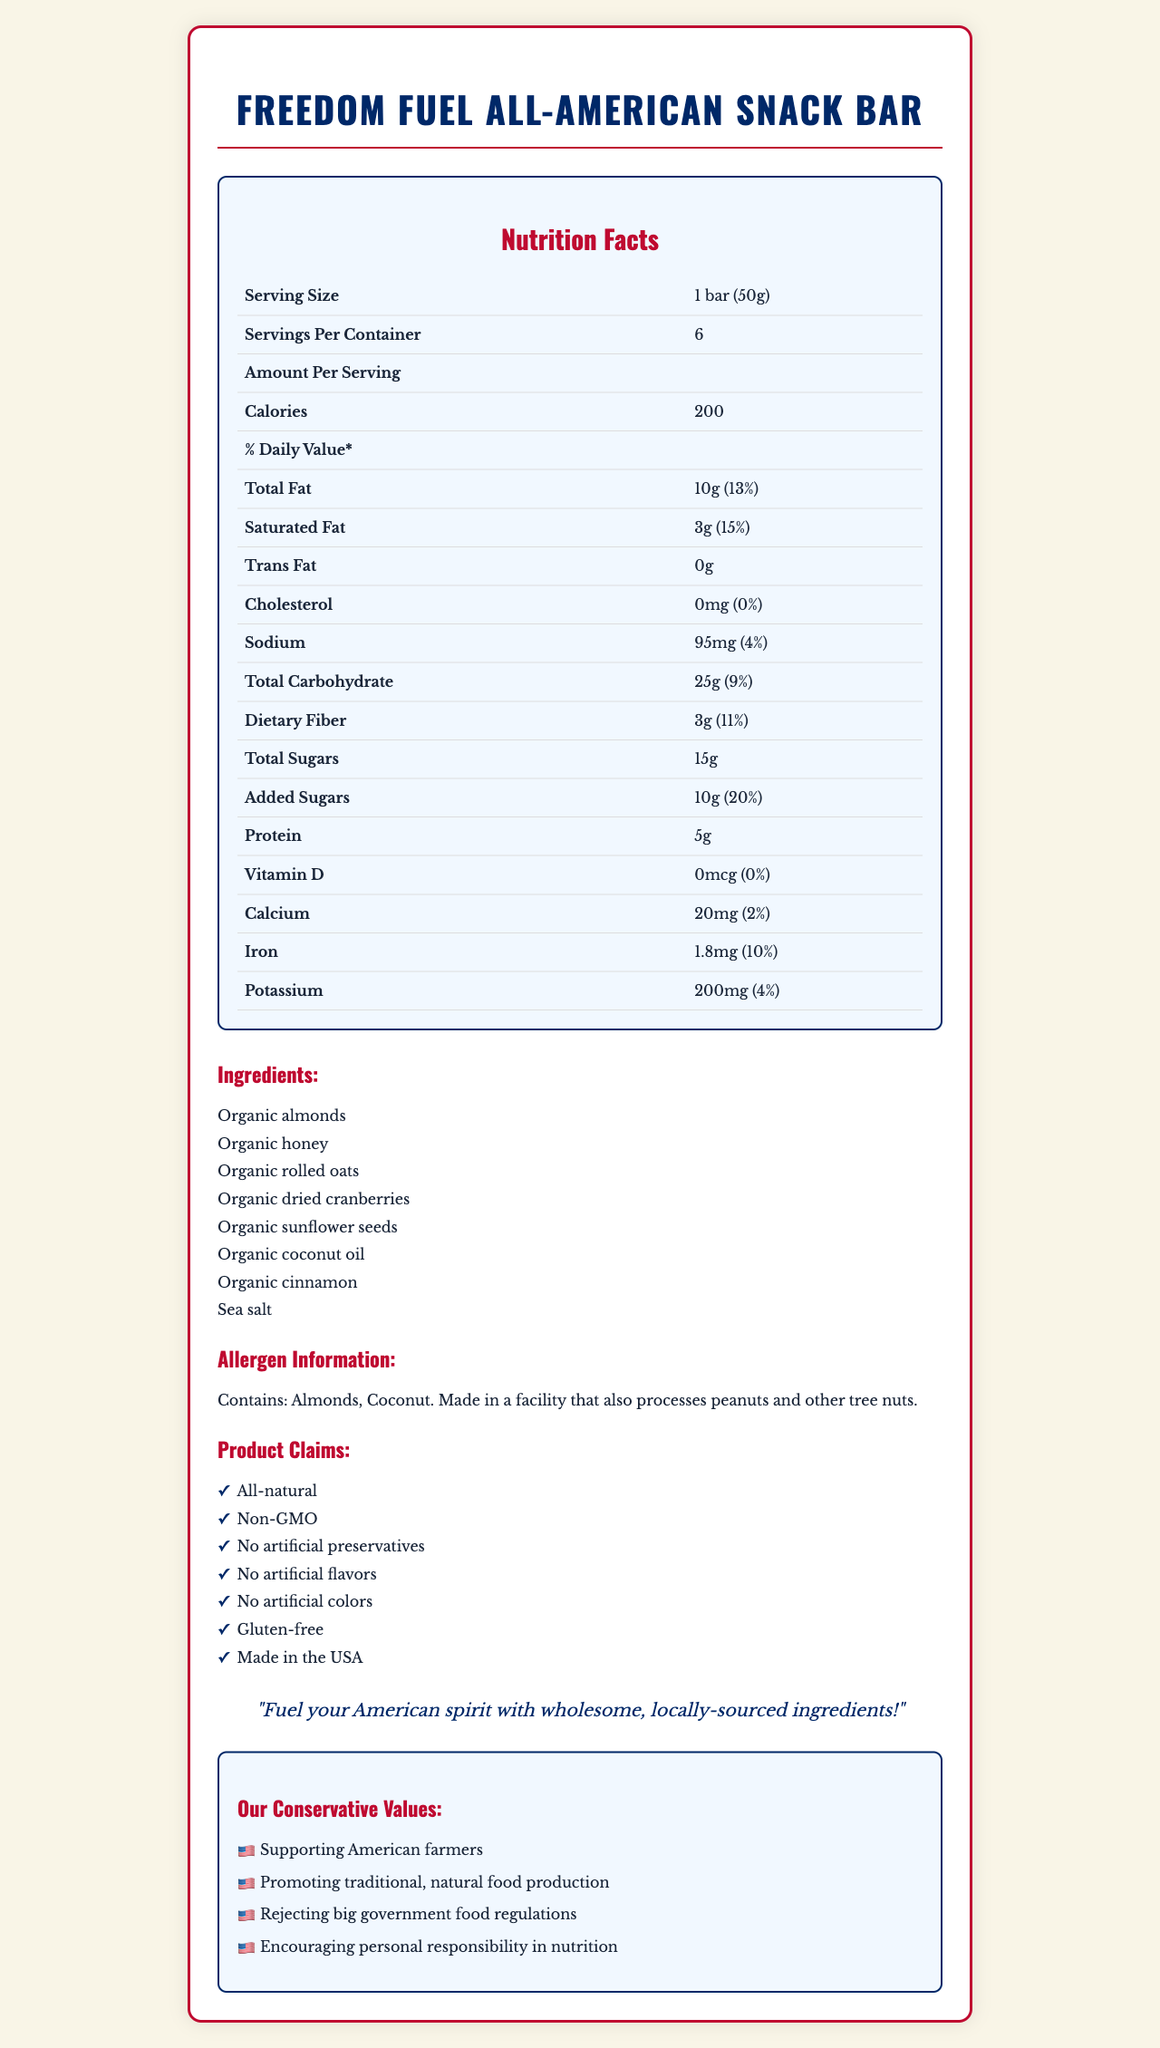how many calories are in one serving of the Freedom Fuel All-American Snack Bar? The document states that there are 200 calories per serving.
Answer: 200 What is the serving size of the Freedom Fuel All-American Snack Bar? The serving size is specified as "1 bar (50g)" in the nutrition facts section.
Answer: 1 bar (50g) How much total fat is in one serving, and what is the daily percentage value? According to the nutrition facts, one serving contains 10g of total fat, which is 13% of the daily value.
Answer: 10g (13%) Name three ingredients found in the Freedom Fuel All-American Snack Bar. The ingredients list includes "Organic almonds," "Organic honey," and "Organic rolled oats," among others.
Answer: Organic almonds, Organic honey, Organic rolled oats What are the patriotic values highlighted in the document? The document lists these patriotic values explicitly in the "Our Conservative Values" section.
Answer: Supporting American farmers, Promoting traditional, natural food production, Rejecting big government food regulations, Encouraging personal responsibility in nutrition What is the sodium content per serving? A. 50mg B. 95mg C. 150mg D. 200mg The document states that there are 95mg of sodium per serving.
Answer: B. 95mg Which of the following is NOT listed as a claim for the Freedom Fuel All-American Snack Bar? A. Non-GMO B. Vegan C. Gluten-free D. All-natural The document claims the snack bar is Non-GMO, Gluten-free, and All-natural, but does not mention it being vegan.
Answer: B. Vegan Does the snack bar contain any artificial ingredients? The document claims the snack bar has no artificial preservatives, flavors, or colors.
Answer: No Summarize the main information given about the Freedom Fuel All-American Snack Bar. The document provides nutrition facts, ingredients, allergen information, product claims, a patriotic message, and conservative values all related to the snack bar.
Answer: The Freedom Fuel All-American Snack Bar is an all-natural, non-GMO, gluten-free product made in the USA. It contains 200 calories per serving (1 bar, 50g), with significant nutrients including 10g of total fat and 15g of total sugars. Its ingredients include organic almonds and honey, and it supports conservative values such as promoting traditional food production and rejecting big government regulations. How much protein is in one serving? The document lists that there are 5g of protein in one serving.
Answer: 5g Can it be determined how many snacks one person can consume per day from the document? The document provides nutrition details but does not specify recommended daily consumption amounts.
Answer: Not enough information What is the message about the origin of the product's ingredients? The patriotic message at the end of the document promotes the use of locally-sourced American ingredients.
Answer: Fuel your American spirit with wholesome, locally-sourced ingredients! 